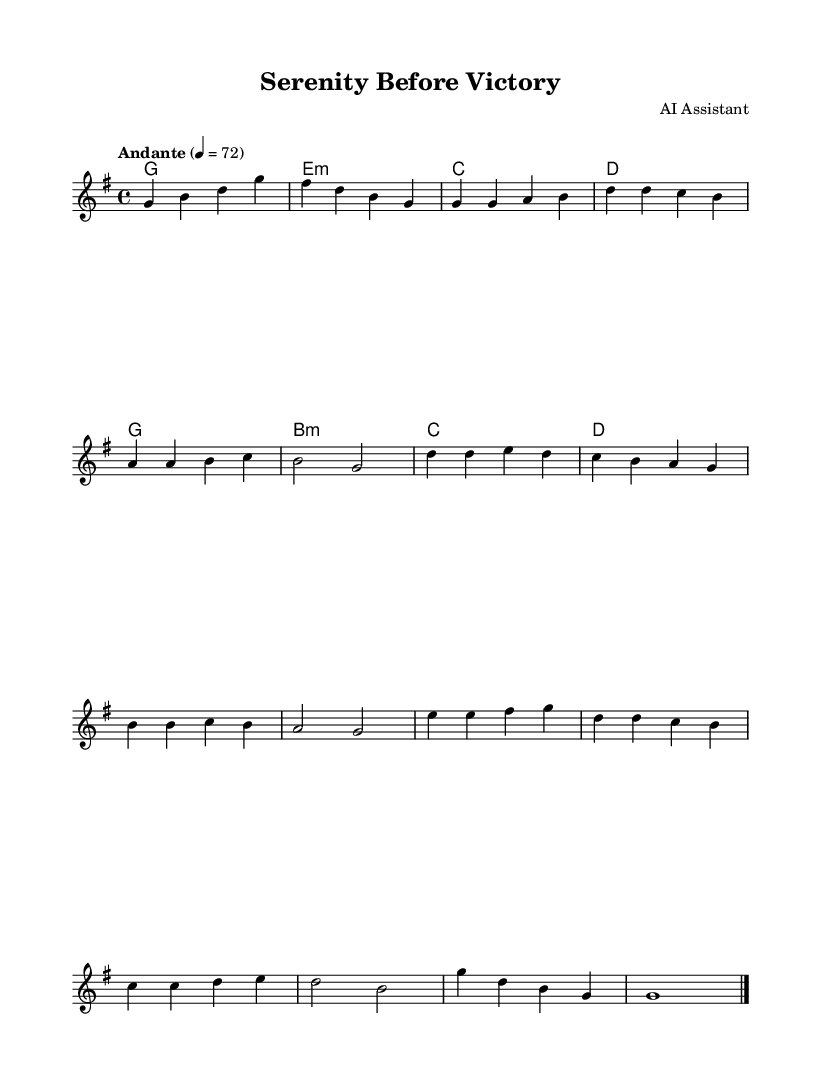What is the key signature of this music? The key signature is G major, which has one sharp (F#). This can be identified by looking at the beginning of the staff where the sharps are indicated.
Answer: G major What is the time signature of this piece? The time signature is 4/4, which is indicated at the beginning of the sheet music. This means there are four beats per measure and the quarter note gets one beat.
Answer: 4/4 What is the tempo marking for this piece? The tempo marking is "Andante," which means a moderate pace. This is displayed above the staff, indicating how fast or slow the piece should be played.
Answer: Andante How many measures are in the melody section? The melody section has a total of 11 measures, which can be counted by looking at the alignments of the bar lines in the melody staff.
Answer: 11 What is the first chord in the harmony section? The first chord in the harmony section is G major, which is shown in the chord names at the beginning of the score.
Answer: G major What is the last note of the melody? The last note of the melody is G, which is indicated at the end of the melody staff in the outro section.
Answer: G What type of music is this classified as? This piece is classified as meditative worship music, which is indicated by its title and the context of being designed for relaxation and mental preparation before competitions.
Answer: Meditative worship music 